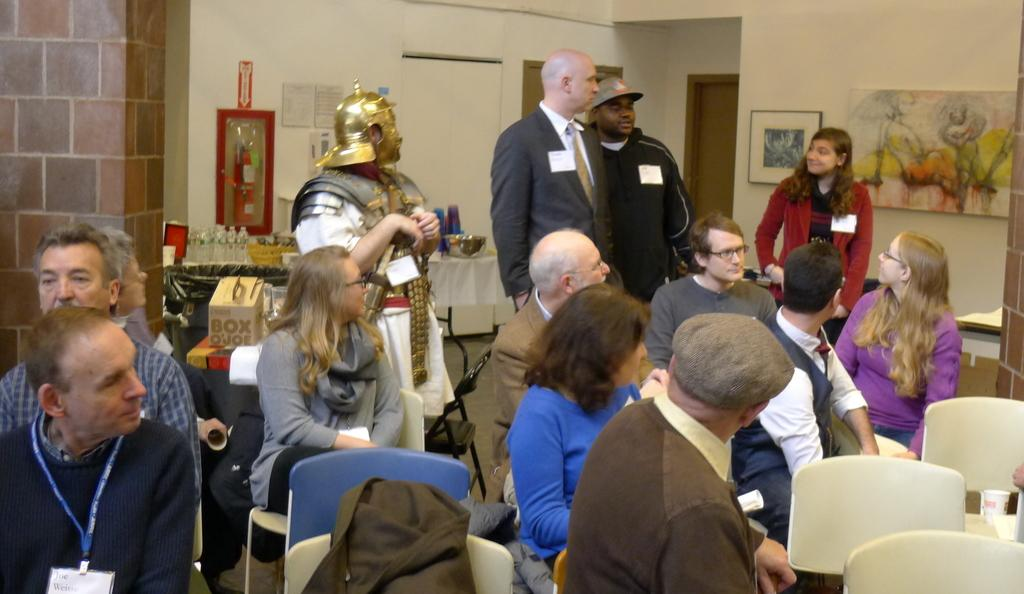What are the people in the image doing? There are persons sitting on chairs in the image, and there are persons standing behind the seated persons. What can be seen in the background of the image? There is a wall in the background of the image, with photo frames on the wall and a door visible. There are also water bottles in the background. Can you describe the arrangement of the people in the image? The seated persons are in front, and the standing persons are behind them. What type of invention is being demonstrated by the goose in the image? There is no goose present in the image, and therefore no invention is being demonstrated. 